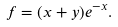Convert formula to latex. <formula><loc_0><loc_0><loc_500><loc_500>f = ( x + y ) e ^ { - x } .</formula> 